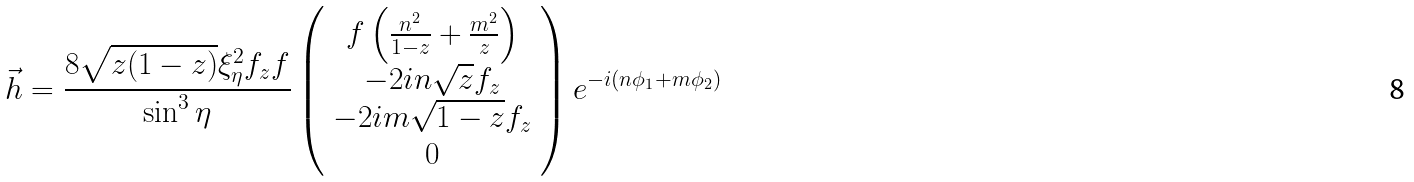Convert formula to latex. <formula><loc_0><loc_0><loc_500><loc_500>\vec { h } = \frac { 8 \sqrt { z ( 1 - z ) } \xi ^ { 2 } _ { \eta } f _ { z } f } { \sin ^ { 3 } \eta } \left ( \begin{array} { c } f \left ( \frac { n ^ { 2 } } { 1 - z } + \frac { m ^ { 2 } } { z } \right ) \\ - 2 i n \sqrt { z } f _ { z } \\ - 2 i m \sqrt { 1 - z } f _ { z } \\ 0 \end{array} \right ) e ^ { - i ( n \phi _ { 1 } + m \phi _ { 2 } ) }</formula> 